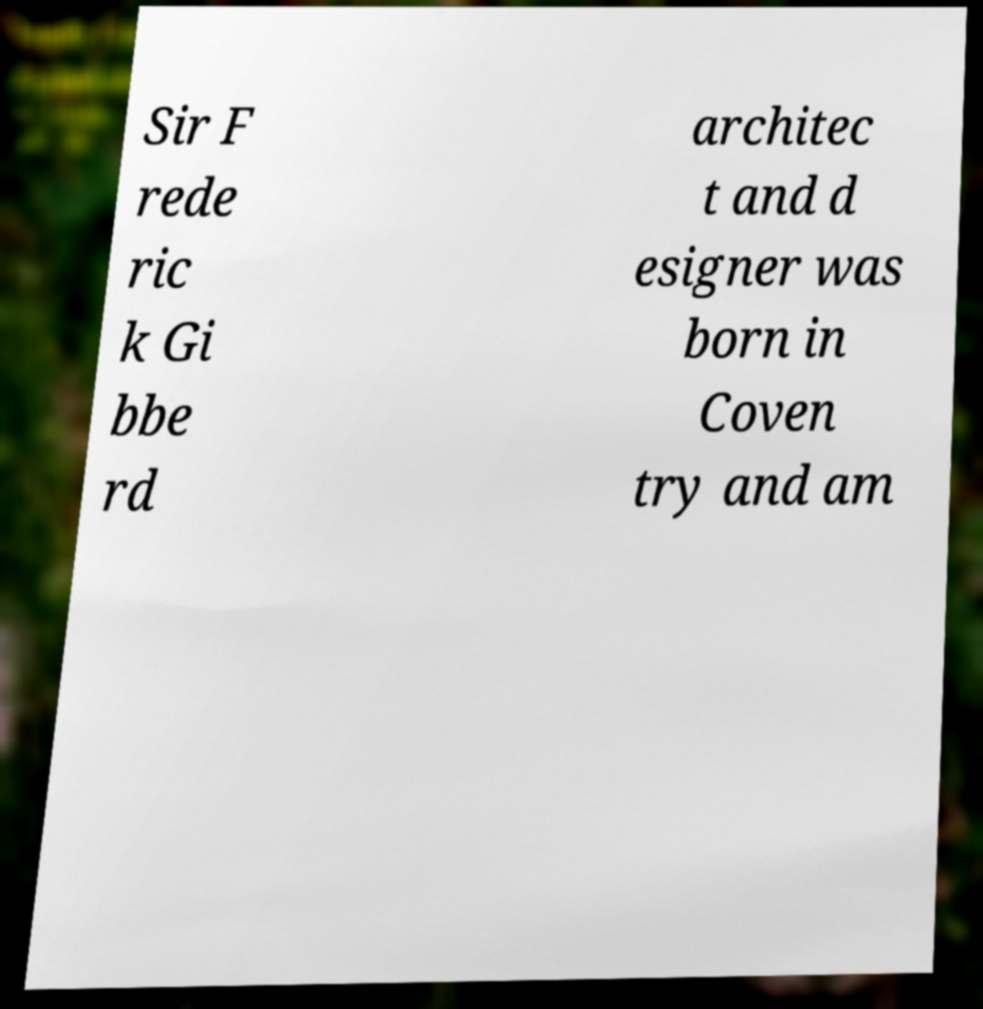For documentation purposes, I need the text within this image transcribed. Could you provide that? Sir F rede ric k Gi bbe rd architec t and d esigner was born in Coven try and am 